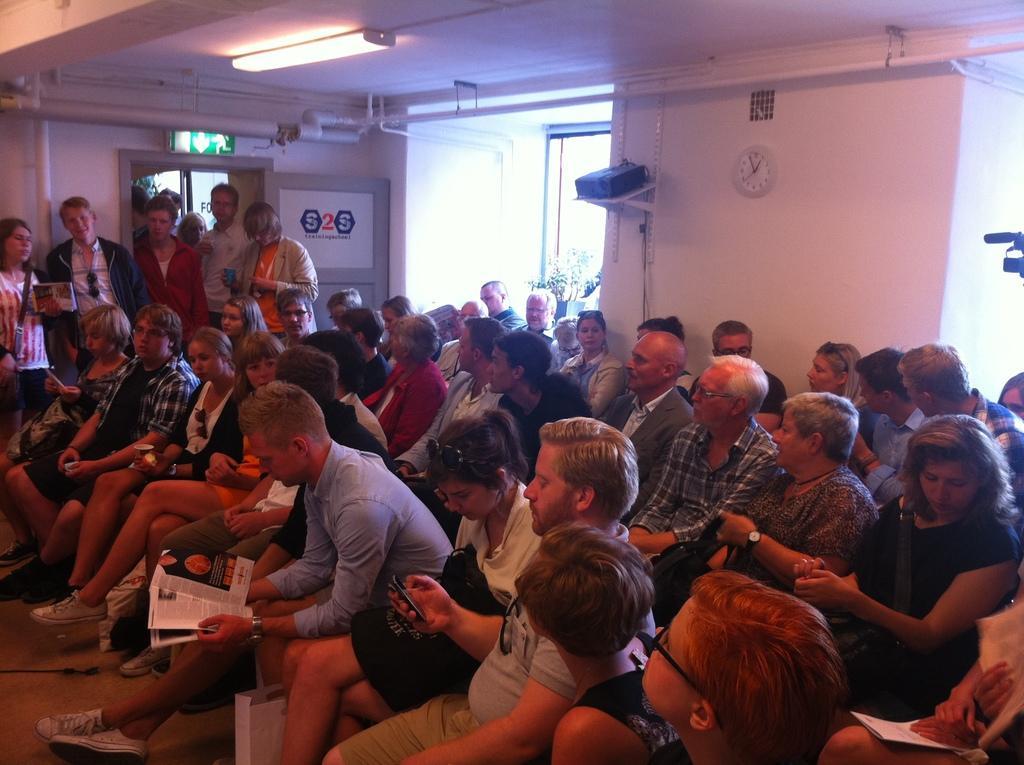Describe this image in one or two sentences. We can see few persons are sitting on the chairs and among them few persons are holding papers, mobiles, cups in their hands. In the background there are few persons standing at the wall, clock on the wall, window, house plant, exit board on the wall, poster on the door and an object on a stand which is attached to the wall. 